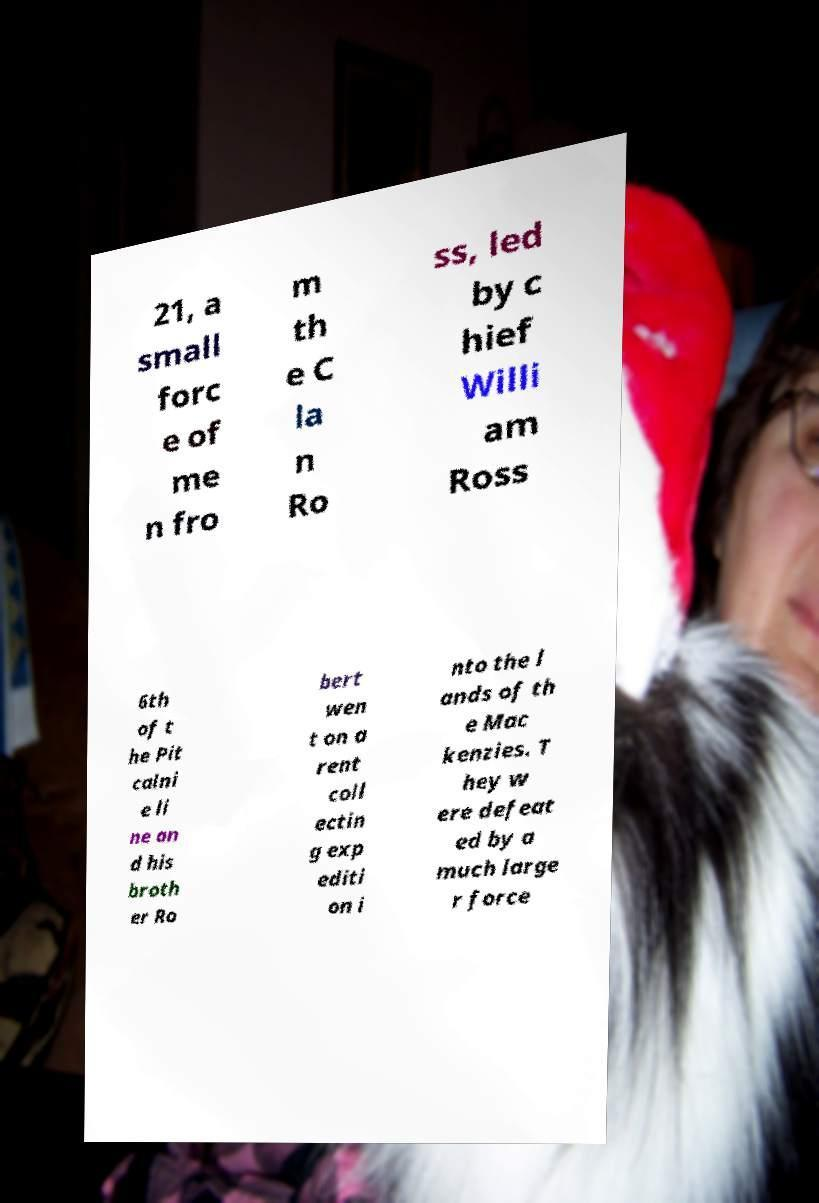Could you assist in decoding the text presented in this image and type it out clearly? 21, a small forc e of me n fro m th e C la n Ro ss, led by c hief Willi am Ross 6th of t he Pit calni e li ne an d his broth er Ro bert wen t on a rent coll ectin g exp editi on i nto the l ands of th e Mac kenzies. T hey w ere defeat ed by a much large r force 